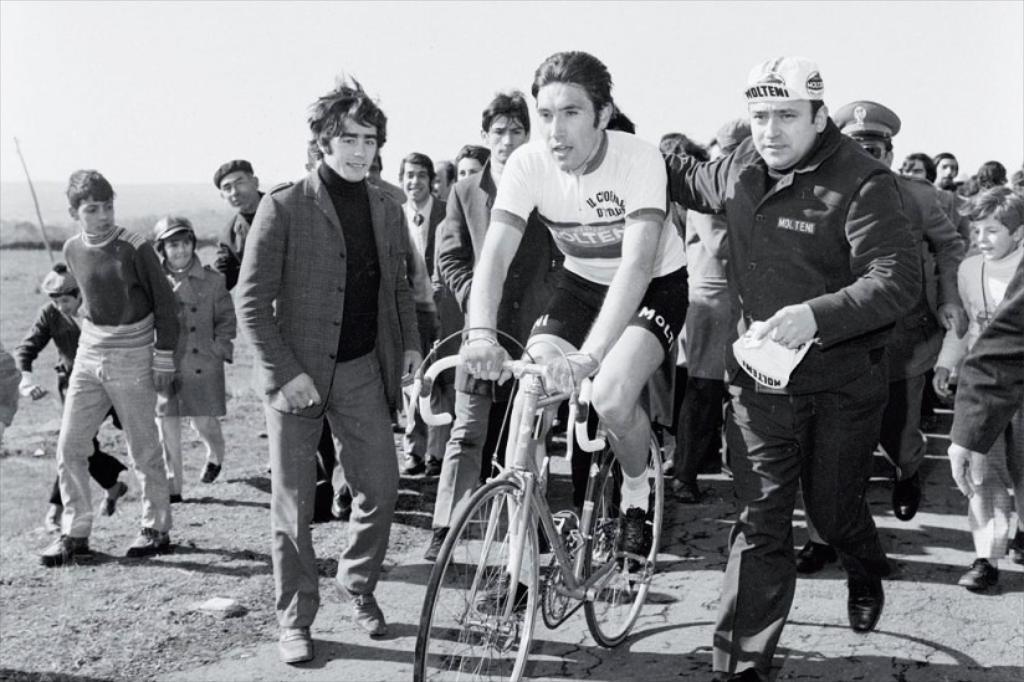How would you summarize this image in a sentence or two? There are many people in the image. There is person riding bicycle. People are walking around the person. 